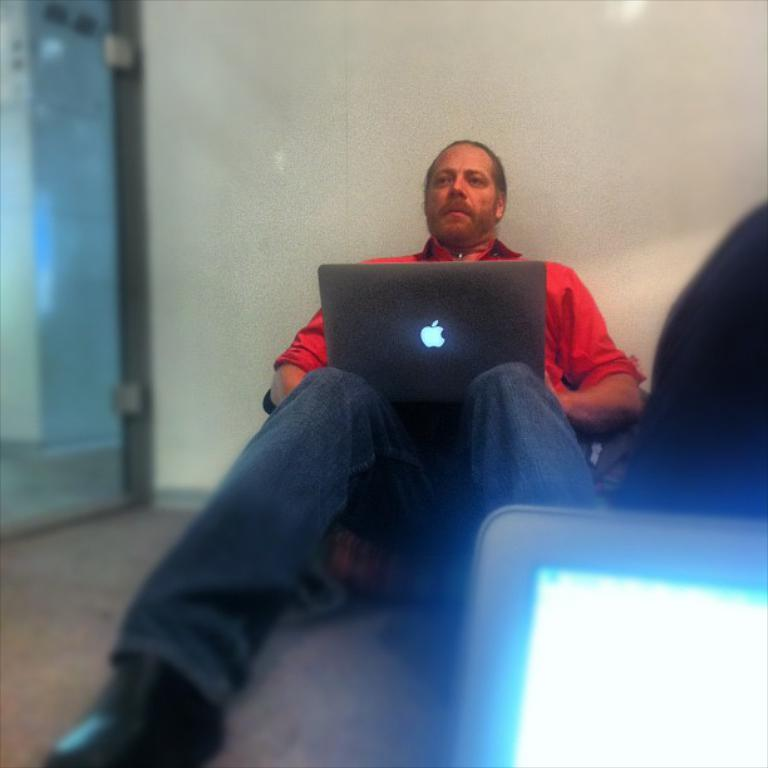Who is the person in the image? There is a man in the image. What is the man carrying in the image? The man is carrying a laptop. What is the man's posture in the image? The man is sitting and leaning against a wall. What type of cream can be seen on the man's face in the image? There is no cream visible on the man's face in the image. What sound does the man make with a whistle in the image? There is no whistle present in the image, so it is not possible to determine what sound the man might make with it. 